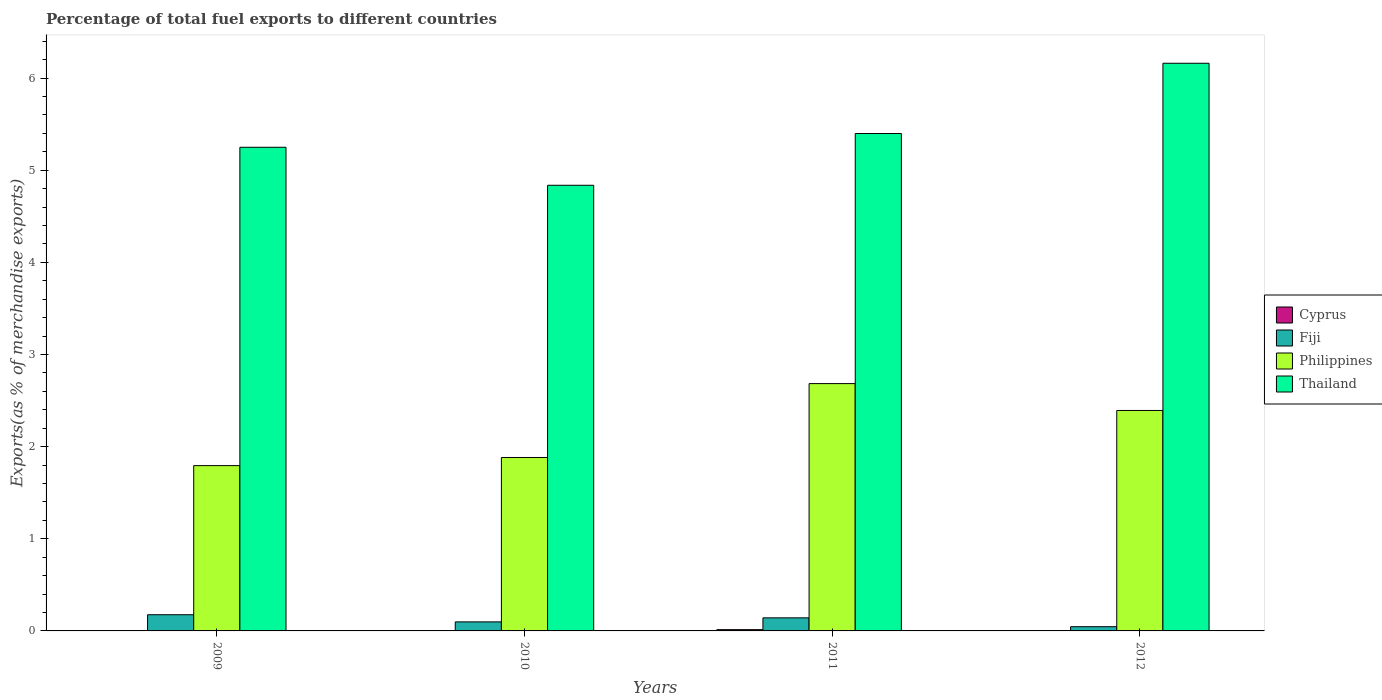How many bars are there on the 3rd tick from the left?
Make the answer very short. 4. How many bars are there on the 3rd tick from the right?
Offer a terse response. 4. What is the label of the 4th group of bars from the left?
Ensure brevity in your answer.  2012. In how many cases, is the number of bars for a given year not equal to the number of legend labels?
Give a very brief answer. 0. What is the percentage of exports to different countries in Cyprus in 2009?
Your response must be concise. 0. Across all years, what is the maximum percentage of exports to different countries in Fiji?
Your answer should be very brief. 0.18. Across all years, what is the minimum percentage of exports to different countries in Cyprus?
Make the answer very short. 9.987264344271967e-6. In which year was the percentage of exports to different countries in Cyprus maximum?
Provide a short and direct response. 2011. What is the total percentage of exports to different countries in Philippines in the graph?
Provide a short and direct response. 8.75. What is the difference between the percentage of exports to different countries in Thailand in 2009 and that in 2012?
Offer a very short reply. -0.91. What is the difference between the percentage of exports to different countries in Thailand in 2011 and the percentage of exports to different countries in Philippines in 2012?
Your answer should be compact. 3.01. What is the average percentage of exports to different countries in Cyprus per year?
Your response must be concise. 0. In the year 2009, what is the difference between the percentage of exports to different countries in Cyprus and percentage of exports to different countries in Thailand?
Your answer should be compact. -5.25. In how many years, is the percentage of exports to different countries in Cyprus greater than 0.2 %?
Your answer should be compact. 0. What is the ratio of the percentage of exports to different countries in Thailand in 2009 to that in 2011?
Your answer should be compact. 0.97. Is the percentage of exports to different countries in Cyprus in 2011 less than that in 2012?
Provide a short and direct response. No. Is the difference between the percentage of exports to different countries in Cyprus in 2010 and 2012 greater than the difference between the percentage of exports to different countries in Thailand in 2010 and 2012?
Your answer should be compact. Yes. What is the difference between the highest and the second highest percentage of exports to different countries in Fiji?
Make the answer very short. 0.03. What is the difference between the highest and the lowest percentage of exports to different countries in Philippines?
Your answer should be very brief. 0.89. Is the sum of the percentage of exports to different countries in Cyprus in 2009 and 2012 greater than the maximum percentage of exports to different countries in Thailand across all years?
Your answer should be very brief. No. Is it the case that in every year, the sum of the percentage of exports to different countries in Fiji and percentage of exports to different countries in Philippines is greater than the sum of percentage of exports to different countries in Cyprus and percentage of exports to different countries in Thailand?
Offer a terse response. No. What does the 2nd bar from the right in 2009 represents?
Your answer should be compact. Philippines. Is it the case that in every year, the sum of the percentage of exports to different countries in Fiji and percentage of exports to different countries in Philippines is greater than the percentage of exports to different countries in Cyprus?
Keep it short and to the point. Yes. How many bars are there?
Provide a succinct answer. 16. How many years are there in the graph?
Provide a succinct answer. 4. Does the graph contain any zero values?
Keep it short and to the point. No. Does the graph contain grids?
Make the answer very short. No. How many legend labels are there?
Make the answer very short. 4. What is the title of the graph?
Offer a terse response. Percentage of total fuel exports to different countries. Does "Belize" appear as one of the legend labels in the graph?
Ensure brevity in your answer.  No. What is the label or title of the X-axis?
Keep it short and to the point. Years. What is the label or title of the Y-axis?
Keep it short and to the point. Exports(as % of merchandise exports). What is the Exports(as % of merchandise exports) of Cyprus in 2009?
Your answer should be compact. 0. What is the Exports(as % of merchandise exports) of Fiji in 2009?
Give a very brief answer. 0.18. What is the Exports(as % of merchandise exports) in Philippines in 2009?
Make the answer very short. 1.79. What is the Exports(as % of merchandise exports) of Thailand in 2009?
Provide a succinct answer. 5.25. What is the Exports(as % of merchandise exports) of Cyprus in 2010?
Make the answer very short. 0. What is the Exports(as % of merchandise exports) in Fiji in 2010?
Provide a short and direct response. 0.1. What is the Exports(as % of merchandise exports) of Philippines in 2010?
Provide a succinct answer. 1.88. What is the Exports(as % of merchandise exports) of Thailand in 2010?
Make the answer very short. 4.84. What is the Exports(as % of merchandise exports) of Cyprus in 2011?
Give a very brief answer. 0.01. What is the Exports(as % of merchandise exports) in Fiji in 2011?
Your response must be concise. 0.14. What is the Exports(as % of merchandise exports) of Philippines in 2011?
Ensure brevity in your answer.  2.68. What is the Exports(as % of merchandise exports) of Thailand in 2011?
Your answer should be compact. 5.4. What is the Exports(as % of merchandise exports) in Cyprus in 2012?
Your answer should be compact. 9.987264344271967e-6. What is the Exports(as % of merchandise exports) of Fiji in 2012?
Offer a terse response. 0.05. What is the Exports(as % of merchandise exports) in Philippines in 2012?
Your answer should be compact. 2.39. What is the Exports(as % of merchandise exports) of Thailand in 2012?
Ensure brevity in your answer.  6.16. Across all years, what is the maximum Exports(as % of merchandise exports) in Cyprus?
Offer a terse response. 0.01. Across all years, what is the maximum Exports(as % of merchandise exports) in Fiji?
Your response must be concise. 0.18. Across all years, what is the maximum Exports(as % of merchandise exports) in Philippines?
Your response must be concise. 2.68. Across all years, what is the maximum Exports(as % of merchandise exports) of Thailand?
Give a very brief answer. 6.16. Across all years, what is the minimum Exports(as % of merchandise exports) of Cyprus?
Your answer should be compact. 9.987264344271967e-6. Across all years, what is the minimum Exports(as % of merchandise exports) in Fiji?
Your response must be concise. 0.05. Across all years, what is the minimum Exports(as % of merchandise exports) in Philippines?
Ensure brevity in your answer.  1.79. Across all years, what is the minimum Exports(as % of merchandise exports) in Thailand?
Ensure brevity in your answer.  4.84. What is the total Exports(as % of merchandise exports) in Cyprus in the graph?
Offer a terse response. 0.02. What is the total Exports(as % of merchandise exports) in Fiji in the graph?
Keep it short and to the point. 0.46. What is the total Exports(as % of merchandise exports) of Philippines in the graph?
Your answer should be compact. 8.75. What is the total Exports(as % of merchandise exports) in Thailand in the graph?
Keep it short and to the point. 21.64. What is the difference between the Exports(as % of merchandise exports) of Cyprus in 2009 and that in 2010?
Your answer should be compact. -0. What is the difference between the Exports(as % of merchandise exports) of Fiji in 2009 and that in 2010?
Ensure brevity in your answer.  0.08. What is the difference between the Exports(as % of merchandise exports) of Philippines in 2009 and that in 2010?
Ensure brevity in your answer.  -0.09. What is the difference between the Exports(as % of merchandise exports) of Thailand in 2009 and that in 2010?
Ensure brevity in your answer.  0.41. What is the difference between the Exports(as % of merchandise exports) of Cyprus in 2009 and that in 2011?
Ensure brevity in your answer.  -0.01. What is the difference between the Exports(as % of merchandise exports) in Fiji in 2009 and that in 2011?
Ensure brevity in your answer.  0.03. What is the difference between the Exports(as % of merchandise exports) of Philippines in 2009 and that in 2011?
Ensure brevity in your answer.  -0.89. What is the difference between the Exports(as % of merchandise exports) in Thailand in 2009 and that in 2011?
Provide a short and direct response. -0.15. What is the difference between the Exports(as % of merchandise exports) of Fiji in 2009 and that in 2012?
Keep it short and to the point. 0.13. What is the difference between the Exports(as % of merchandise exports) of Philippines in 2009 and that in 2012?
Ensure brevity in your answer.  -0.6. What is the difference between the Exports(as % of merchandise exports) in Thailand in 2009 and that in 2012?
Provide a succinct answer. -0.91. What is the difference between the Exports(as % of merchandise exports) in Cyprus in 2010 and that in 2011?
Offer a very short reply. -0.01. What is the difference between the Exports(as % of merchandise exports) in Fiji in 2010 and that in 2011?
Give a very brief answer. -0.04. What is the difference between the Exports(as % of merchandise exports) of Philippines in 2010 and that in 2011?
Your answer should be very brief. -0.8. What is the difference between the Exports(as % of merchandise exports) of Thailand in 2010 and that in 2011?
Offer a terse response. -0.56. What is the difference between the Exports(as % of merchandise exports) of Cyprus in 2010 and that in 2012?
Provide a succinct answer. 0. What is the difference between the Exports(as % of merchandise exports) of Fiji in 2010 and that in 2012?
Provide a short and direct response. 0.05. What is the difference between the Exports(as % of merchandise exports) of Philippines in 2010 and that in 2012?
Give a very brief answer. -0.51. What is the difference between the Exports(as % of merchandise exports) of Thailand in 2010 and that in 2012?
Your answer should be very brief. -1.32. What is the difference between the Exports(as % of merchandise exports) of Cyprus in 2011 and that in 2012?
Keep it short and to the point. 0.01. What is the difference between the Exports(as % of merchandise exports) of Fiji in 2011 and that in 2012?
Keep it short and to the point. 0.1. What is the difference between the Exports(as % of merchandise exports) in Philippines in 2011 and that in 2012?
Offer a terse response. 0.29. What is the difference between the Exports(as % of merchandise exports) of Thailand in 2011 and that in 2012?
Make the answer very short. -0.76. What is the difference between the Exports(as % of merchandise exports) of Cyprus in 2009 and the Exports(as % of merchandise exports) of Fiji in 2010?
Provide a succinct answer. -0.1. What is the difference between the Exports(as % of merchandise exports) of Cyprus in 2009 and the Exports(as % of merchandise exports) of Philippines in 2010?
Provide a short and direct response. -1.88. What is the difference between the Exports(as % of merchandise exports) in Cyprus in 2009 and the Exports(as % of merchandise exports) in Thailand in 2010?
Provide a succinct answer. -4.84. What is the difference between the Exports(as % of merchandise exports) of Fiji in 2009 and the Exports(as % of merchandise exports) of Philippines in 2010?
Give a very brief answer. -1.71. What is the difference between the Exports(as % of merchandise exports) in Fiji in 2009 and the Exports(as % of merchandise exports) in Thailand in 2010?
Keep it short and to the point. -4.66. What is the difference between the Exports(as % of merchandise exports) in Philippines in 2009 and the Exports(as % of merchandise exports) in Thailand in 2010?
Offer a very short reply. -3.04. What is the difference between the Exports(as % of merchandise exports) of Cyprus in 2009 and the Exports(as % of merchandise exports) of Fiji in 2011?
Offer a terse response. -0.14. What is the difference between the Exports(as % of merchandise exports) of Cyprus in 2009 and the Exports(as % of merchandise exports) of Philippines in 2011?
Provide a short and direct response. -2.68. What is the difference between the Exports(as % of merchandise exports) in Cyprus in 2009 and the Exports(as % of merchandise exports) in Thailand in 2011?
Keep it short and to the point. -5.4. What is the difference between the Exports(as % of merchandise exports) in Fiji in 2009 and the Exports(as % of merchandise exports) in Philippines in 2011?
Provide a short and direct response. -2.51. What is the difference between the Exports(as % of merchandise exports) in Fiji in 2009 and the Exports(as % of merchandise exports) in Thailand in 2011?
Make the answer very short. -5.22. What is the difference between the Exports(as % of merchandise exports) in Philippines in 2009 and the Exports(as % of merchandise exports) in Thailand in 2011?
Provide a short and direct response. -3.6. What is the difference between the Exports(as % of merchandise exports) of Cyprus in 2009 and the Exports(as % of merchandise exports) of Fiji in 2012?
Offer a very short reply. -0.05. What is the difference between the Exports(as % of merchandise exports) in Cyprus in 2009 and the Exports(as % of merchandise exports) in Philippines in 2012?
Offer a terse response. -2.39. What is the difference between the Exports(as % of merchandise exports) of Cyprus in 2009 and the Exports(as % of merchandise exports) of Thailand in 2012?
Offer a terse response. -6.16. What is the difference between the Exports(as % of merchandise exports) in Fiji in 2009 and the Exports(as % of merchandise exports) in Philippines in 2012?
Keep it short and to the point. -2.22. What is the difference between the Exports(as % of merchandise exports) of Fiji in 2009 and the Exports(as % of merchandise exports) of Thailand in 2012?
Your answer should be very brief. -5.98. What is the difference between the Exports(as % of merchandise exports) of Philippines in 2009 and the Exports(as % of merchandise exports) of Thailand in 2012?
Offer a terse response. -4.37. What is the difference between the Exports(as % of merchandise exports) in Cyprus in 2010 and the Exports(as % of merchandise exports) in Fiji in 2011?
Your answer should be compact. -0.14. What is the difference between the Exports(as % of merchandise exports) in Cyprus in 2010 and the Exports(as % of merchandise exports) in Philippines in 2011?
Give a very brief answer. -2.68. What is the difference between the Exports(as % of merchandise exports) of Cyprus in 2010 and the Exports(as % of merchandise exports) of Thailand in 2011?
Give a very brief answer. -5.4. What is the difference between the Exports(as % of merchandise exports) of Fiji in 2010 and the Exports(as % of merchandise exports) of Philippines in 2011?
Offer a very short reply. -2.59. What is the difference between the Exports(as % of merchandise exports) in Fiji in 2010 and the Exports(as % of merchandise exports) in Thailand in 2011?
Offer a very short reply. -5.3. What is the difference between the Exports(as % of merchandise exports) in Philippines in 2010 and the Exports(as % of merchandise exports) in Thailand in 2011?
Offer a terse response. -3.52. What is the difference between the Exports(as % of merchandise exports) in Cyprus in 2010 and the Exports(as % of merchandise exports) in Fiji in 2012?
Offer a terse response. -0.04. What is the difference between the Exports(as % of merchandise exports) of Cyprus in 2010 and the Exports(as % of merchandise exports) of Philippines in 2012?
Your response must be concise. -2.39. What is the difference between the Exports(as % of merchandise exports) in Cyprus in 2010 and the Exports(as % of merchandise exports) in Thailand in 2012?
Your answer should be compact. -6.16. What is the difference between the Exports(as % of merchandise exports) in Fiji in 2010 and the Exports(as % of merchandise exports) in Philippines in 2012?
Your answer should be very brief. -2.29. What is the difference between the Exports(as % of merchandise exports) of Fiji in 2010 and the Exports(as % of merchandise exports) of Thailand in 2012?
Keep it short and to the point. -6.06. What is the difference between the Exports(as % of merchandise exports) in Philippines in 2010 and the Exports(as % of merchandise exports) in Thailand in 2012?
Your answer should be very brief. -4.28. What is the difference between the Exports(as % of merchandise exports) of Cyprus in 2011 and the Exports(as % of merchandise exports) of Fiji in 2012?
Provide a succinct answer. -0.03. What is the difference between the Exports(as % of merchandise exports) in Cyprus in 2011 and the Exports(as % of merchandise exports) in Philippines in 2012?
Your answer should be very brief. -2.38. What is the difference between the Exports(as % of merchandise exports) in Cyprus in 2011 and the Exports(as % of merchandise exports) in Thailand in 2012?
Give a very brief answer. -6.15. What is the difference between the Exports(as % of merchandise exports) in Fiji in 2011 and the Exports(as % of merchandise exports) in Philippines in 2012?
Ensure brevity in your answer.  -2.25. What is the difference between the Exports(as % of merchandise exports) in Fiji in 2011 and the Exports(as % of merchandise exports) in Thailand in 2012?
Provide a succinct answer. -6.02. What is the difference between the Exports(as % of merchandise exports) of Philippines in 2011 and the Exports(as % of merchandise exports) of Thailand in 2012?
Your answer should be very brief. -3.48. What is the average Exports(as % of merchandise exports) of Cyprus per year?
Keep it short and to the point. 0. What is the average Exports(as % of merchandise exports) of Fiji per year?
Offer a very short reply. 0.12. What is the average Exports(as % of merchandise exports) of Philippines per year?
Offer a terse response. 2.19. What is the average Exports(as % of merchandise exports) of Thailand per year?
Give a very brief answer. 5.41. In the year 2009, what is the difference between the Exports(as % of merchandise exports) of Cyprus and Exports(as % of merchandise exports) of Fiji?
Keep it short and to the point. -0.18. In the year 2009, what is the difference between the Exports(as % of merchandise exports) of Cyprus and Exports(as % of merchandise exports) of Philippines?
Ensure brevity in your answer.  -1.79. In the year 2009, what is the difference between the Exports(as % of merchandise exports) in Cyprus and Exports(as % of merchandise exports) in Thailand?
Give a very brief answer. -5.25. In the year 2009, what is the difference between the Exports(as % of merchandise exports) of Fiji and Exports(as % of merchandise exports) of Philippines?
Provide a succinct answer. -1.62. In the year 2009, what is the difference between the Exports(as % of merchandise exports) in Fiji and Exports(as % of merchandise exports) in Thailand?
Keep it short and to the point. -5.07. In the year 2009, what is the difference between the Exports(as % of merchandise exports) in Philippines and Exports(as % of merchandise exports) in Thailand?
Provide a short and direct response. -3.46. In the year 2010, what is the difference between the Exports(as % of merchandise exports) in Cyprus and Exports(as % of merchandise exports) in Fiji?
Provide a succinct answer. -0.1. In the year 2010, what is the difference between the Exports(as % of merchandise exports) of Cyprus and Exports(as % of merchandise exports) of Philippines?
Keep it short and to the point. -1.88. In the year 2010, what is the difference between the Exports(as % of merchandise exports) of Cyprus and Exports(as % of merchandise exports) of Thailand?
Offer a very short reply. -4.83. In the year 2010, what is the difference between the Exports(as % of merchandise exports) in Fiji and Exports(as % of merchandise exports) in Philippines?
Give a very brief answer. -1.78. In the year 2010, what is the difference between the Exports(as % of merchandise exports) in Fiji and Exports(as % of merchandise exports) in Thailand?
Provide a short and direct response. -4.74. In the year 2010, what is the difference between the Exports(as % of merchandise exports) of Philippines and Exports(as % of merchandise exports) of Thailand?
Offer a very short reply. -2.95. In the year 2011, what is the difference between the Exports(as % of merchandise exports) of Cyprus and Exports(as % of merchandise exports) of Fiji?
Offer a very short reply. -0.13. In the year 2011, what is the difference between the Exports(as % of merchandise exports) in Cyprus and Exports(as % of merchandise exports) in Philippines?
Provide a short and direct response. -2.67. In the year 2011, what is the difference between the Exports(as % of merchandise exports) in Cyprus and Exports(as % of merchandise exports) in Thailand?
Make the answer very short. -5.38. In the year 2011, what is the difference between the Exports(as % of merchandise exports) of Fiji and Exports(as % of merchandise exports) of Philippines?
Provide a short and direct response. -2.54. In the year 2011, what is the difference between the Exports(as % of merchandise exports) in Fiji and Exports(as % of merchandise exports) in Thailand?
Your response must be concise. -5.26. In the year 2011, what is the difference between the Exports(as % of merchandise exports) of Philippines and Exports(as % of merchandise exports) of Thailand?
Make the answer very short. -2.71. In the year 2012, what is the difference between the Exports(as % of merchandise exports) of Cyprus and Exports(as % of merchandise exports) of Fiji?
Ensure brevity in your answer.  -0.05. In the year 2012, what is the difference between the Exports(as % of merchandise exports) of Cyprus and Exports(as % of merchandise exports) of Philippines?
Offer a very short reply. -2.39. In the year 2012, what is the difference between the Exports(as % of merchandise exports) of Cyprus and Exports(as % of merchandise exports) of Thailand?
Your answer should be compact. -6.16. In the year 2012, what is the difference between the Exports(as % of merchandise exports) of Fiji and Exports(as % of merchandise exports) of Philippines?
Offer a very short reply. -2.35. In the year 2012, what is the difference between the Exports(as % of merchandise exports) in Fiji and Exports(as % of merchandise exports) in Thailand?
Make the answer very short. -6.11. In the year 2012, what is the difference between the Exports(as % of merchandise exports) in Philippines and Exports(as % of merchandise exports) in Thailand?
Your answer should be compact. -3.77. What is the ratio of the Exports(as % of merchandise exports) in Cyprus in 2009 to that in 2010?
Keep it short and to the point. 0.17. What is the ratio of the Exports(as % of merchandise exports) of Fiji in 2009 to that in 2010?
Your answer should be very brief. 1.79. What is the ratio of the Exports(as % of merchandise exports) of Philippines in 2009 to that in 2010?
Make the answer very short. 0.95. What is the ratio of the Exports(as % of merchandise exports) in Thailand in 2009 to that in 2010?
Provide a succinct answer. 1.09. What is the ratio of the Exports(as % of merchandise exports) of Cyprus in 2009 to that in 2011?
Provide a short and direct response. 0.03. What is the ratio of the Exports(as % of merchandise exports) of Fiji in 2009 to that in 2011?
Your answer should be compact. 1.24. What is the ratio of the Exports(as % of merchandise exports) in Philippines in 2009 to that in 2011?
Ensure brevity in your answer.  0.67. What is the ratio of the Exports(as % of merchandise exports) in Thailand in 2009 to that in 2011?
Make the answer very short. 0.97. What is the ratio of the Exports(as % of merchandise exports) in Cyprus in 2009 to that in 2012?
Offer a very short reply. 39.8. What is the ratio of the Exports(as % of merchandise exports) in Fiji in 2009 to that in 2012?
Offer a terse response. 3.83. What is the ratio of the Exports(as % of merchandise exports) of Philippines in 2009 to that in 2012?
Your answer should be compact. 0.75. What is the ratio of the Exports(as % of merchandise exports) of Thailand in 2009 to that in 2012?
Give a very brief answer. 0.85. What is the ratio of the Exports(as % of merchandise exports) of Cyprus in 2010 to that in 2011?
Offer a terse response. 0.17. What is the ratio of the Exports(as % of merchandise exports) of Fiji in 2010 to that in 2011?
Your answer should be very brief. 0.69. What is the ratio of the Exports(as % of merchandise exports) in Philippines in 2010 to that in 2011?
Give a very brief answer. 0.7. What is the ratio of the Exports(as % of merchandise exports) of Thailand in 2010 to that in 2011?
Your response must be concise. 0.9. What is the ratio of the Exports(as % of merchandise exports) in Cyprus in 2010 to that in 2012?
Keep it short and to the point. 240.72. What is the ratio of the Exports(as % of merchandise exports) of Fiji in 2010 to that in 2012?
Ensure brevity in your answer.  2.14. What is the ratio of the Exports(as % of merchandise exports) in Philippines in 2010 to that in 2012?
Make the answer very short. 0.79. What is the ratio of the Exports(as % of merchandise exports) in Thailand in 2010 to that in 2012?
Keep it short and to the point. 0.79. What is the ratio of the Exports(as % of merchandise exports) in Cyprus in 2011 to that in 2012?
Ensure brevity in your answer.  1391.4. What is the ratio of the Exports(as % of merchandise exports) in Fiji in 2011 to that in 2012?
Keep it short and to the point. 3.09. What is the ratio of the Exports(as % of merchandise exports) in Philippines in 2011 to that in 2012?
Provide a succinct answer. 1.12. What is the ratio of the Exports(as % of merchandise exports) of Thailand in 2011 to that in 2012?
Your answer should be compact. 0.88. What is the difference between the highest and the second highest Exports(as % of merchandise exports) of Cyprus?
Provide a short and direct response. 0.01. What is the difference between the highest and the second highest Exports(as % of merchandise exports) in Fiji?
Give a very brief answer. 0.03. What is the difference between the highest and the second highest Exports(as % of merchandise exports) of Philippines?
Give a very brief answer. 0.29. What is the difference between the highest and the second highest Exports(as % of merchandise exports) in Thailand?
Your answer should be very brief. 0.76. What is the difference between the highest and the lowest Exports(as % of merchandise exports) in Cyprus?
Make the answer very short. 0.01. What is the difference between the highest and the lowest Exports(as % of merchandise exports) of Fiji?
Ensure brevity in your answer.  0.13. What is the difference between the highest and the lowest Exports(as % of merchandise exports) of Philippines?
Ensure brevity in your answer.  0.89. What is the difference between the highest and the lowest Exports(as % of merchandise exports) of Thailand?
Provide a succinct answer. 1.32. 